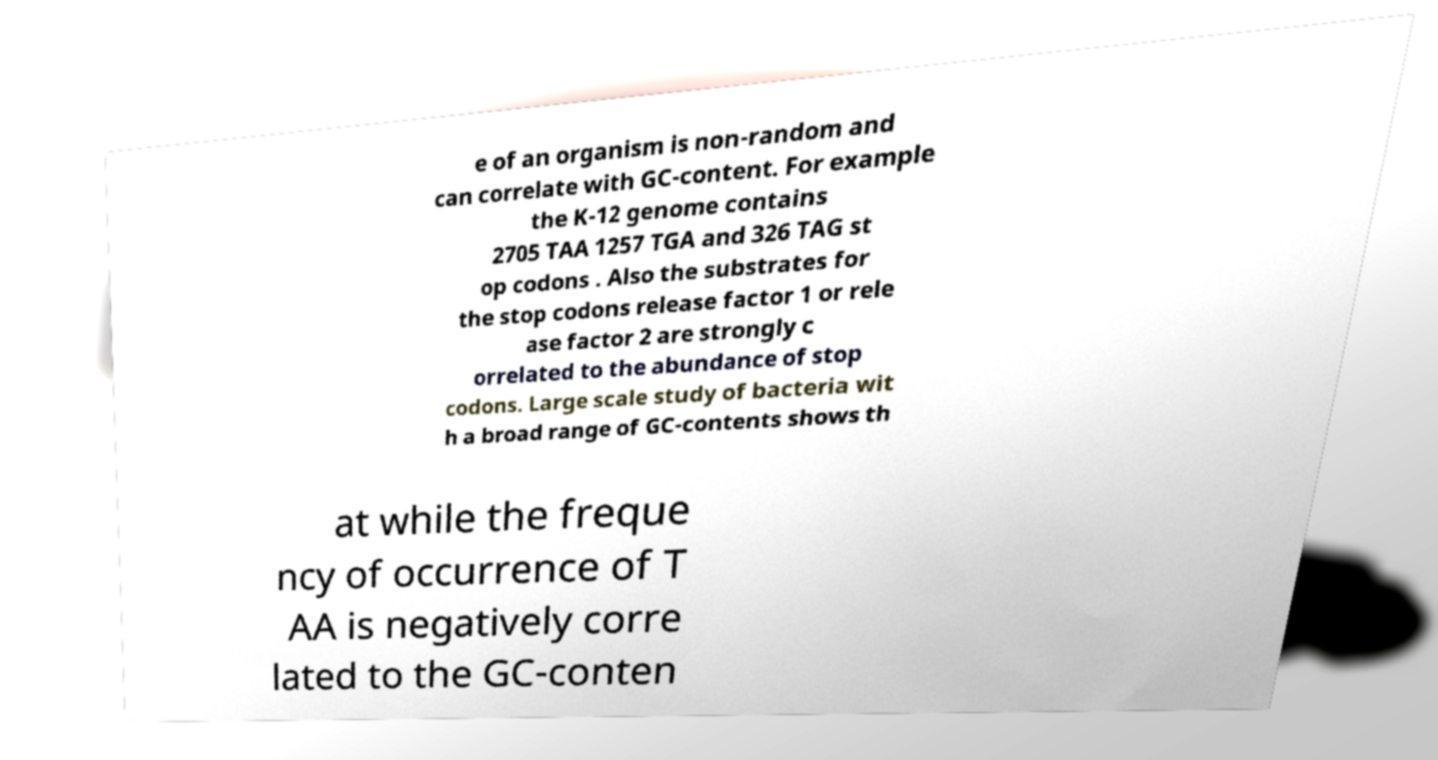Can you read and provide the text displayed in the image?This photo seems to have some interesting text. Can you extract and type it out for me? e of an organism is non-random and can correlate with GC-content. For example the K-12 genome contains 2705 TAA 1257 TGA and 326 TAG st op codons . Also the substrates for the stop codons release factor 1 or rele ase factor 2 are strongly c orrelated to the abundance of stop codons. Large scale study of bacteria wit h a broad range of GC-contents shows th at while the freque ncy of occurrence of T AA is negatively corre lated to the GC-conten 